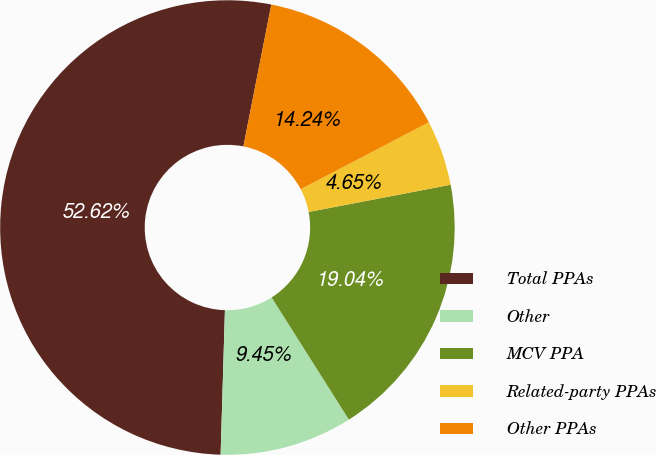<chart> <loc_0><loc_0><loc_500><loc_500><pie_chart><fcel>Total PPAs<fcel>Other<fcel>MCV PPA<fcel>Related-party PPAs<fcel>Other PPAs<nl><fcel>52.62%<fcel>9.45%<fcel>19.04%<fcel>4.65%<fcel>14.24%<nl></chart> 